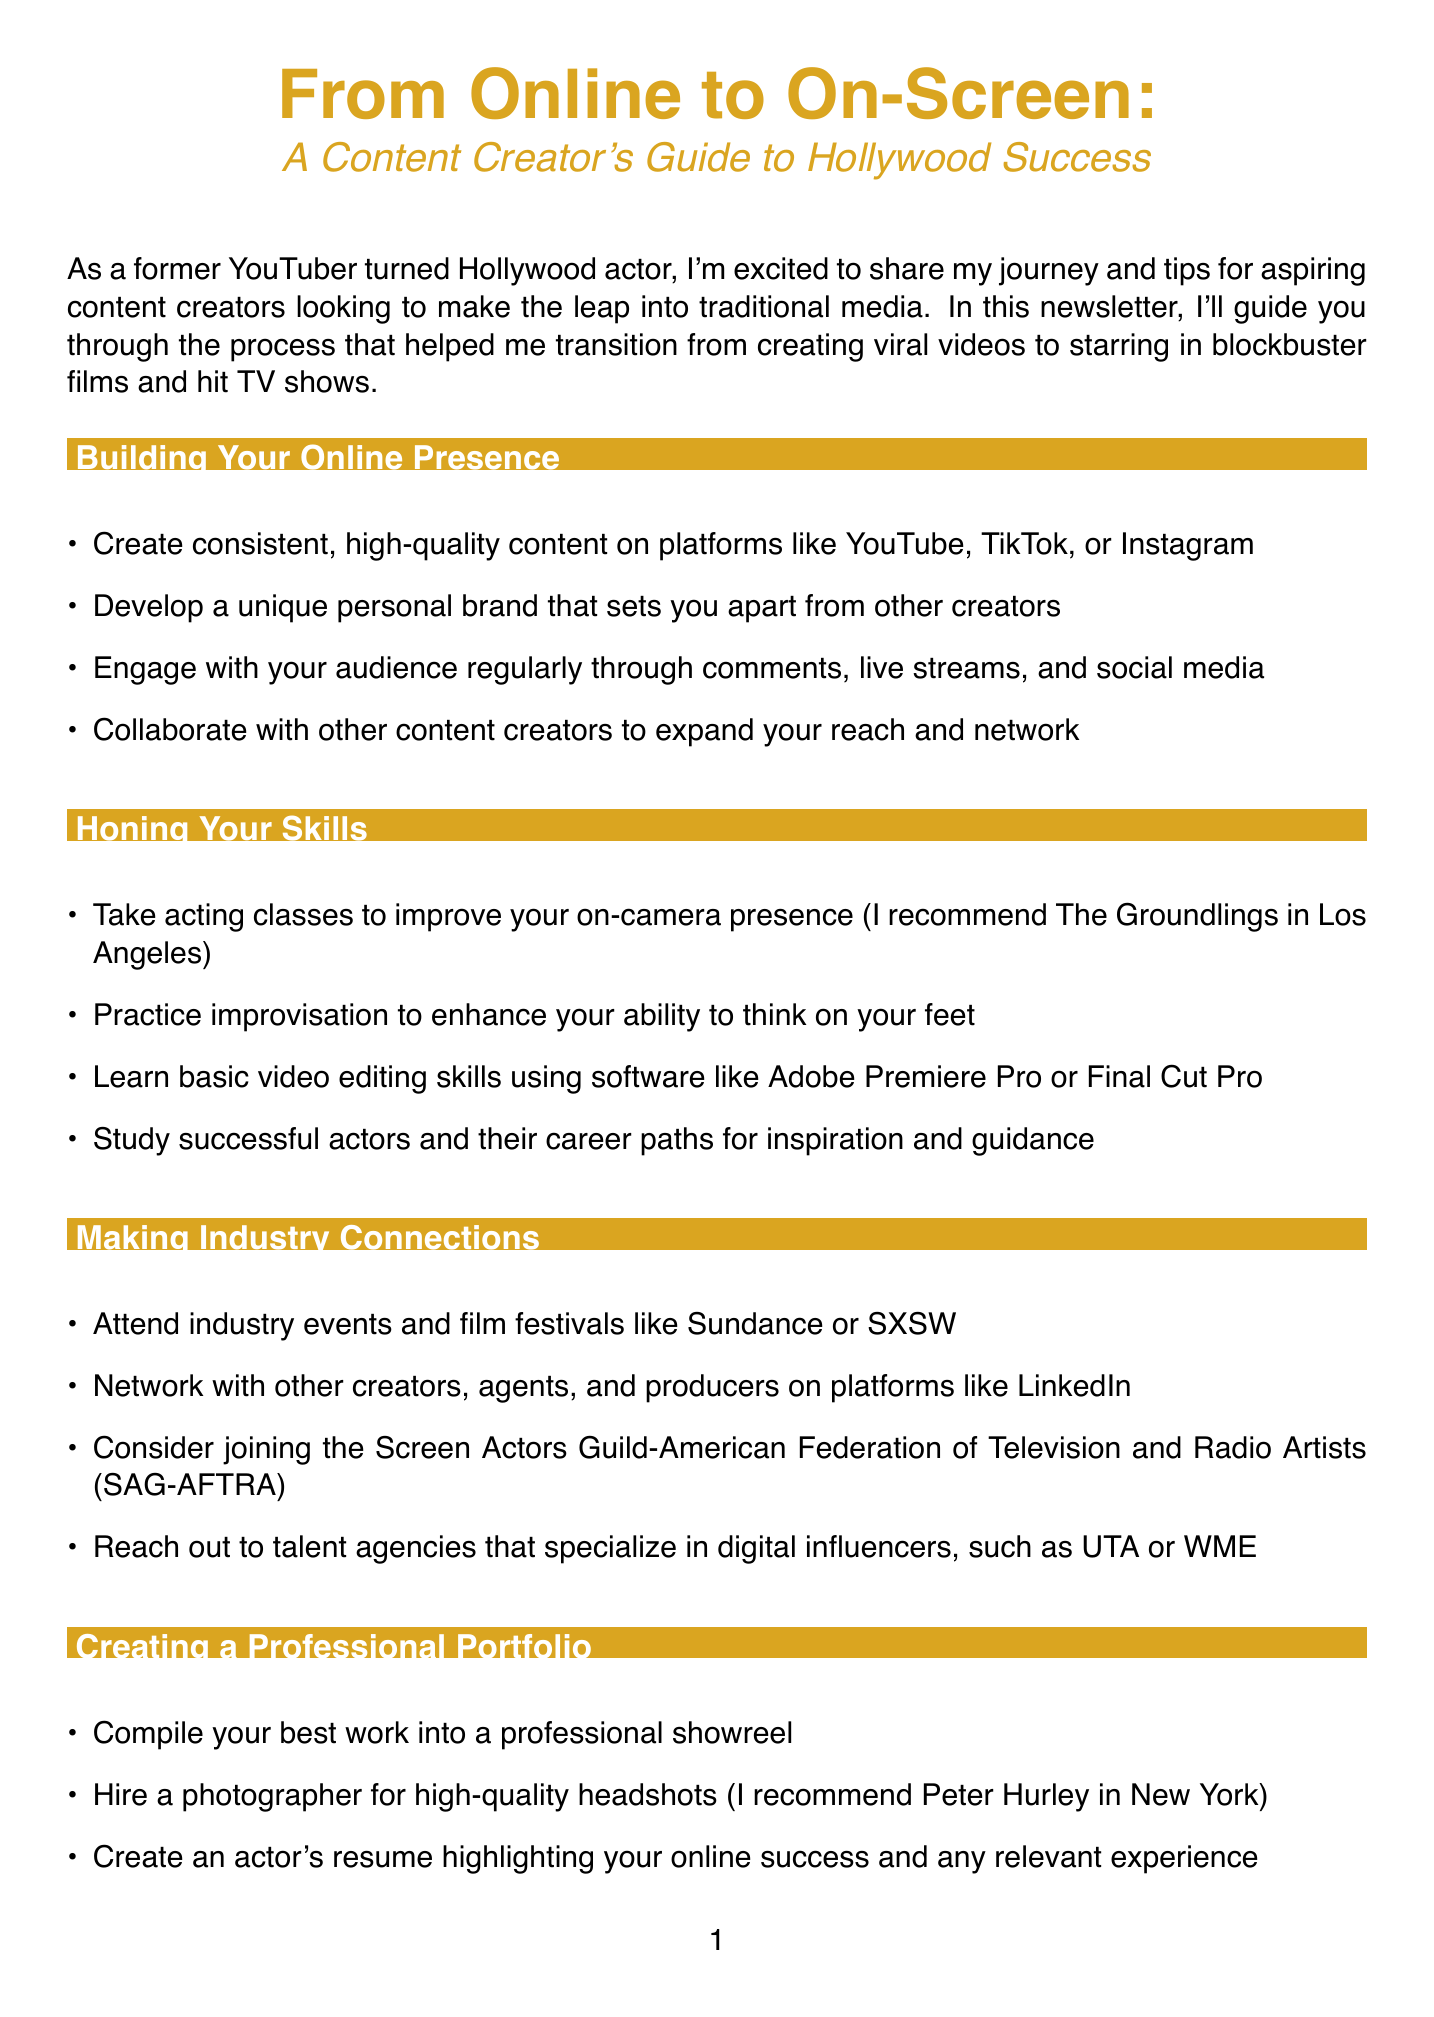What is the title of the newsletter? The title is presented at the beginning of the document as the main focus.
Answer: From Online to On-Screen: A Content Creator's Guide to Hollywood Success What year did the author start their YouTube channel? This information is mentioned in the case study section detailing the author's journey.
Answer: 2015 Which acting school is recommended for improving on-camera presence? The author suggests a specific school known for acting classes.
Answer: The Groundlings What is the name of the series the author landed a recurring role in? The case study specifies the title of the popular Netflix series.
Answer: Stranger Things What agency did the author get representation from after networking? The document includes details on industry connections made by the author.
Answer: UTA How many subscribers did the author's YouTube channel gain within two years? This statistic highlights the author's success as a content creator.
Answer: 2 million What is one key tip for engaging with your audience? The section on building your online presence gives advice on audience interaction.
Answer: Engage with your audience regularly What should be included in a professional actor's resume? The content specifies elements of a professional portfolio.
Answer: Online success and any relevant experience How important is patience in transitioning to traditional media according to the author? The document emphasizes the value of patience during the transition.
Answer: Very important 